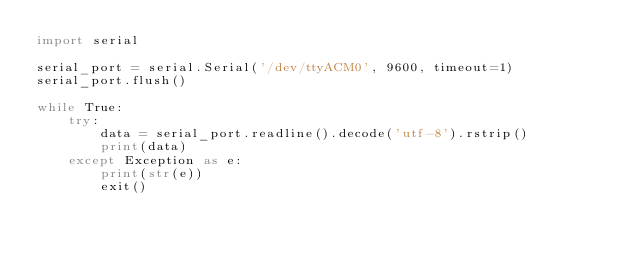Convert code to text. <code><loc_0><loc_0><loc_500><loc_500><_Python_>import serial

serial_port = serial.Serial('/dev/ttyACM0', 9600, timeout=1)
serial_port.flush()

while True:
    try:
        data = serial_port.readline().decode('utf-8').rstrip()
        print(data)
    except Exception as e:
        print(str(e))
        exit()
</code> 